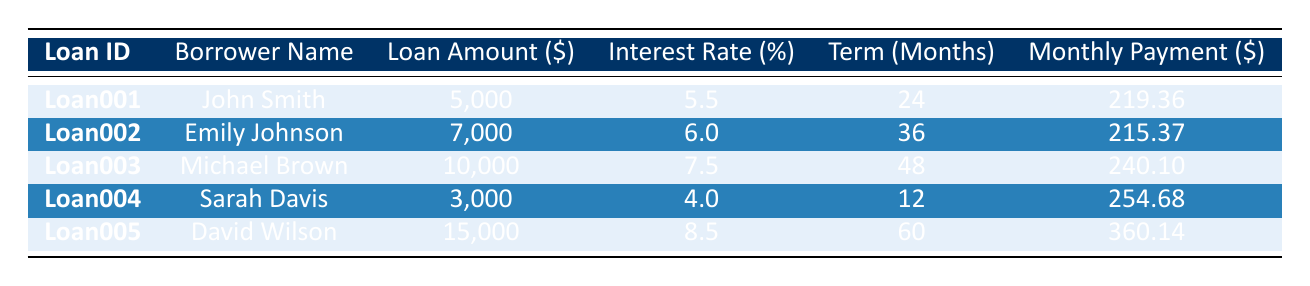What is the loan amount for John Smith? The loan amount for John Smith is found directly in the table under his row, which is indicated as 5,000.
Answer: 5,000 Which borrower has the highest interest rate? To answer this, I compare the interest rates listed in the table. David Wilson has an interest rate of 8.5%, which is higher than the others.
Answer: David Wilson What is the total loan amount from all borrowers? I add the loan amounts for all borrowers: 5,000 + 7,000 + 10,000 + 3,000 + 15,000 = 40,000.
Answer: 40,000 Is Sarah Davis's monthly payment greater than 250? Looking at the monthly payment for Sarah Davis, which is 254.68, I can confirm that it is indeed greater than 250.
Answer: Yes How many months will it take for Emily Johnson to pay off her loan compared to John Smith? The loan term for Emily Johnson is 36 months and for John Smith, it is 24 months. The difference is 36 - 24 = 12 months, meaning Emily takes 12 months longer to pay off her loan.
Answer: 12 months What is the average monthly payment across all loans? I calculate the total monthly payments: 219.36 + 215.37 + 240.10 + 254.68 + 360.14 = 1,289.65. Then, I divide by the number of loans, which is 5: 1,289.65 / 5 = 257.93.
Answer: 257.93 Which borrower pays less than 220 per month? I check the monthly payment for each borrower and see that John Smith (219.36) and Emily Johnson (215.37) have monthly payments below 220.
Answer: Yes What is the difference between the most and least expensive monthly payments? The highest monthly payment is David Wilson at 360.14 and the lowest is Emily Johnson at 215.37. The difference is 360.14 - 215.37 = 144.77.
Answer: 144.77 What percentage of the total loan amount does Michael Brown represent? The total loan amount is 40,000, and Michael Brown’s loan amount is 10,000. The percentage is (10,000 / 40,000) * 100 = 25%.
Answer: 25% 